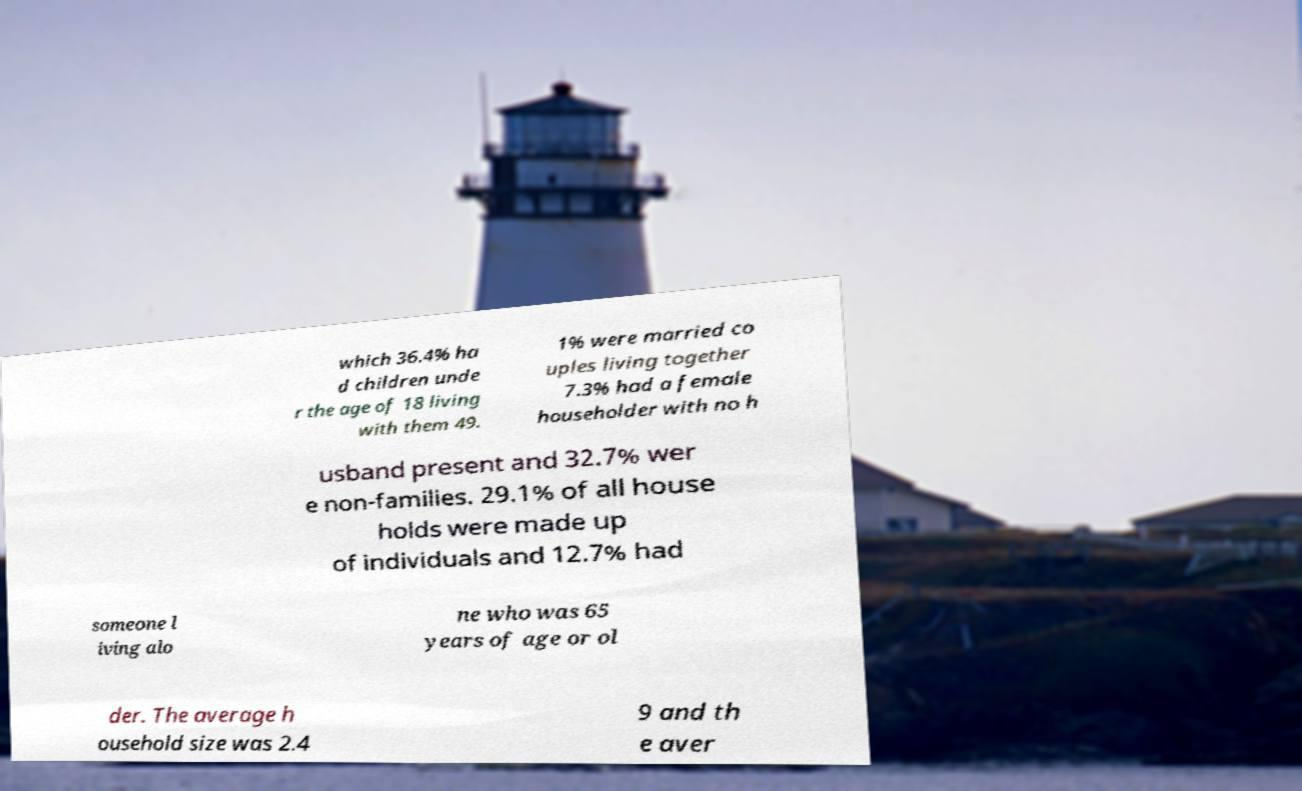For documentation purposes, I need the text within this image transcribed. Could you provide that? which 36.4% ha d children unde r the age of 18 living with them 49. 1% were married co uples living together 7.3% had a female householder with no h usband present and 32.7% wer e non-families. 29.1% of all house holds were made up of individuals and 12.7% had someone l iving alo ne who was 65 years of age or ol der. The average h ousehold size was 2.4 9 and th e aver 